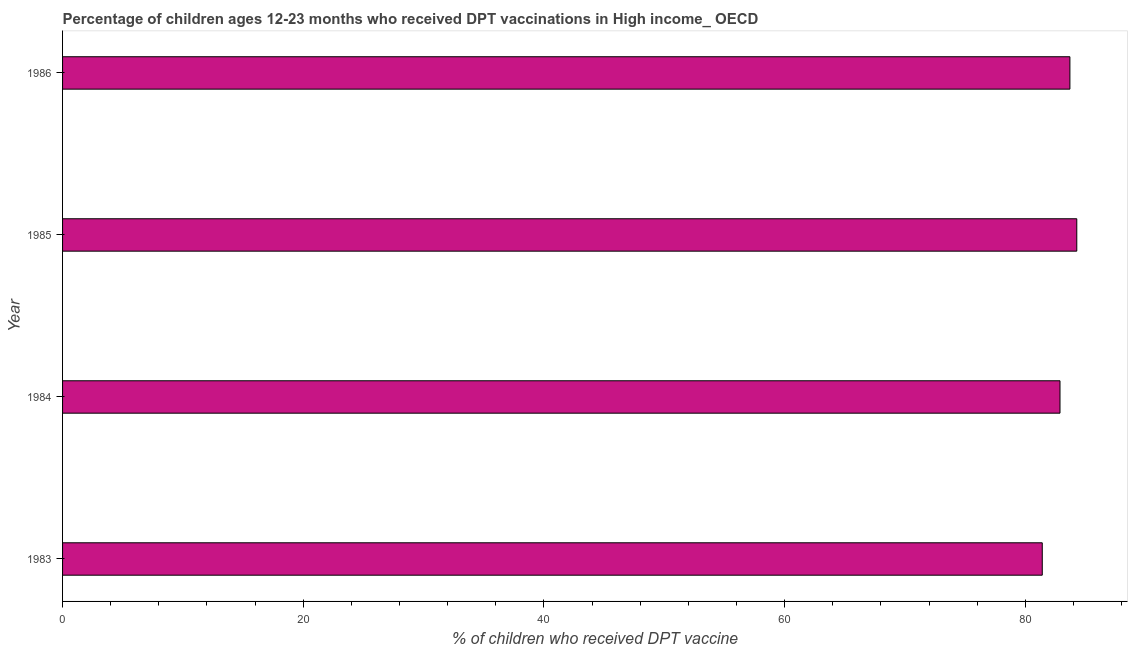Does the graph contain any zero values?
Give a very brief answer. No. Does the graph contain grids?
Offer a very short reply. No. What is the title of the graph?
Offer a very short reply. Percentage of children ages 12-23 months who received DPT vaccinations in High income_ OECD. What is the label or title of the X-axis?
Your answer should be very brief. % of children who received DPT vaccine. What is the percentage of children who received dpt vaccine in 1986?
Keep it short and to the point. 83.7. Across all years, what is the maximum percentage of children who received dpt vaccine?
Provide a succinct answer. 84.27. Across all years, what is the minimum percentage of children who received dpt vaccine?
Make the answer very short. 81.4. In which year was the percentage of children who received dpt vaccine maximum?
Offer a terse response. 1985. In which year was the percentage of children who received dpt vaccine minimum?
Give a very brief answer. 1983. What is the sum of the percentage of children who received dpt vaccine?
Offer a terse response. 332.25. What is the difference between the percentage of children who received dpt vaccine in 1983 and 1984?
Give a very brief answer. -1.47. What is the average percentage of children who received dpt vaccine per year?
Your response must be concise. 83.06. What is the median percentage of children who received dpt vaccine?
Offer a very short reply. 83.29. In how many years, is the percentage of children who received dpt vaccine greater than 72 %?
Give a very brief answer. 4. Do a majority of the years between 1984 and 1985 (inclusive) have percentage of children who received dpt vaccine greater than 84 %?
Offer a very short reply. No. Is the percentage of children who received dpt vaccine in 1983 less than that in 1985?
Provide a succinct answer. Yes. Is the difference between the percentage of children who received dpt vaccine in 1985 and 1986 greater than the difference between any two years?
Your answer should be compact. No. What is the difference between the highest and the second highest percentage of children who received dpt vaccine?
Provide a succinct answer. 0.57. What is the difference between the highest and the lowest percentage of children who received dpt vaccine?
Give a very brief answer. 2.87. In how many years, is the percentage of children who received dpt vaccine greater than the average percentage of children who received dpt vaccine taken over all years?
Your answer should be very brief. 2. How many bars are there?
Make the answer very short. 4. What is the difference between two consecutive major ticks on the X-axis?
Offer a very short reply. 20. What is the % of children who received DPT vaccine in 1983?
Offer a terse response. 81.4. What is the % of children who received DPT vaccine in 1984?
Keep it short and to the point. 82.88. What is the % of children who received DPT vaccine of 1985?
Offer a terse response. 84.27. What is the % of children who received DPT vaccine in 1986?
Your answer should be compact. 83.7. What is the difference between the % of children who received DPT vaccine in 1983 and 1984?
Your answer should be very brief. -1.47. What is the difference between the % of children who received DPT vaccine in 1983 and 1985?
Provide a short and direct response. -2.87. What is the difference between the % of children who received DPT vaccine in 1983 and 1986?
Your answer should be very brief. -2.3. What is the difference between the % of children who received DPT vaccine in 1984 and 1985?
Make the answer very short. -1.39. What is the difference between the % of children who received DPT vaccine in 1984 and 1986?
Provide a short and direct response. -0.82. What is the difference between the % of children who received DPT vaccine in 1985 and 1986?
Provide a succinct answer. 0.57. What is the ratio of the % of children who received DPT vaccine in 1983 to that in 1985?
Provide a succinct answer. 0.97. What is the ratio of the % of children who received DPT vaccine in 1983 to that in 1986?
Give a very brief answer. 0.97. What is the ratio of the % of children who received DPT vaccine in 1984 to that in 1985?
Make the answer very short. 0.98. What is the ratio of the % of children who received DPT vaccine in 1984 to that in 1986?
Make the answer very short. 0.99. 